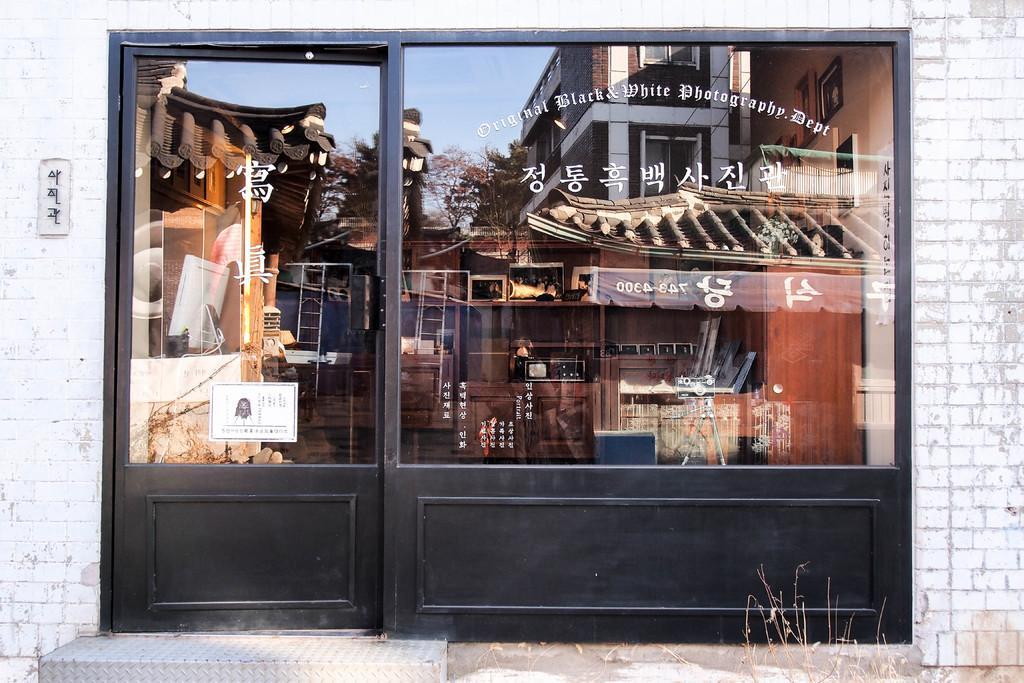How would you summarize this image in a sentence or two? In this image I see a store over here and I see the door and I see something is written on the glasses and I can also see the reflection of buildings, trees and the sky on the glasses and I see the steps over here and I see the wall I see something is written over here too. 